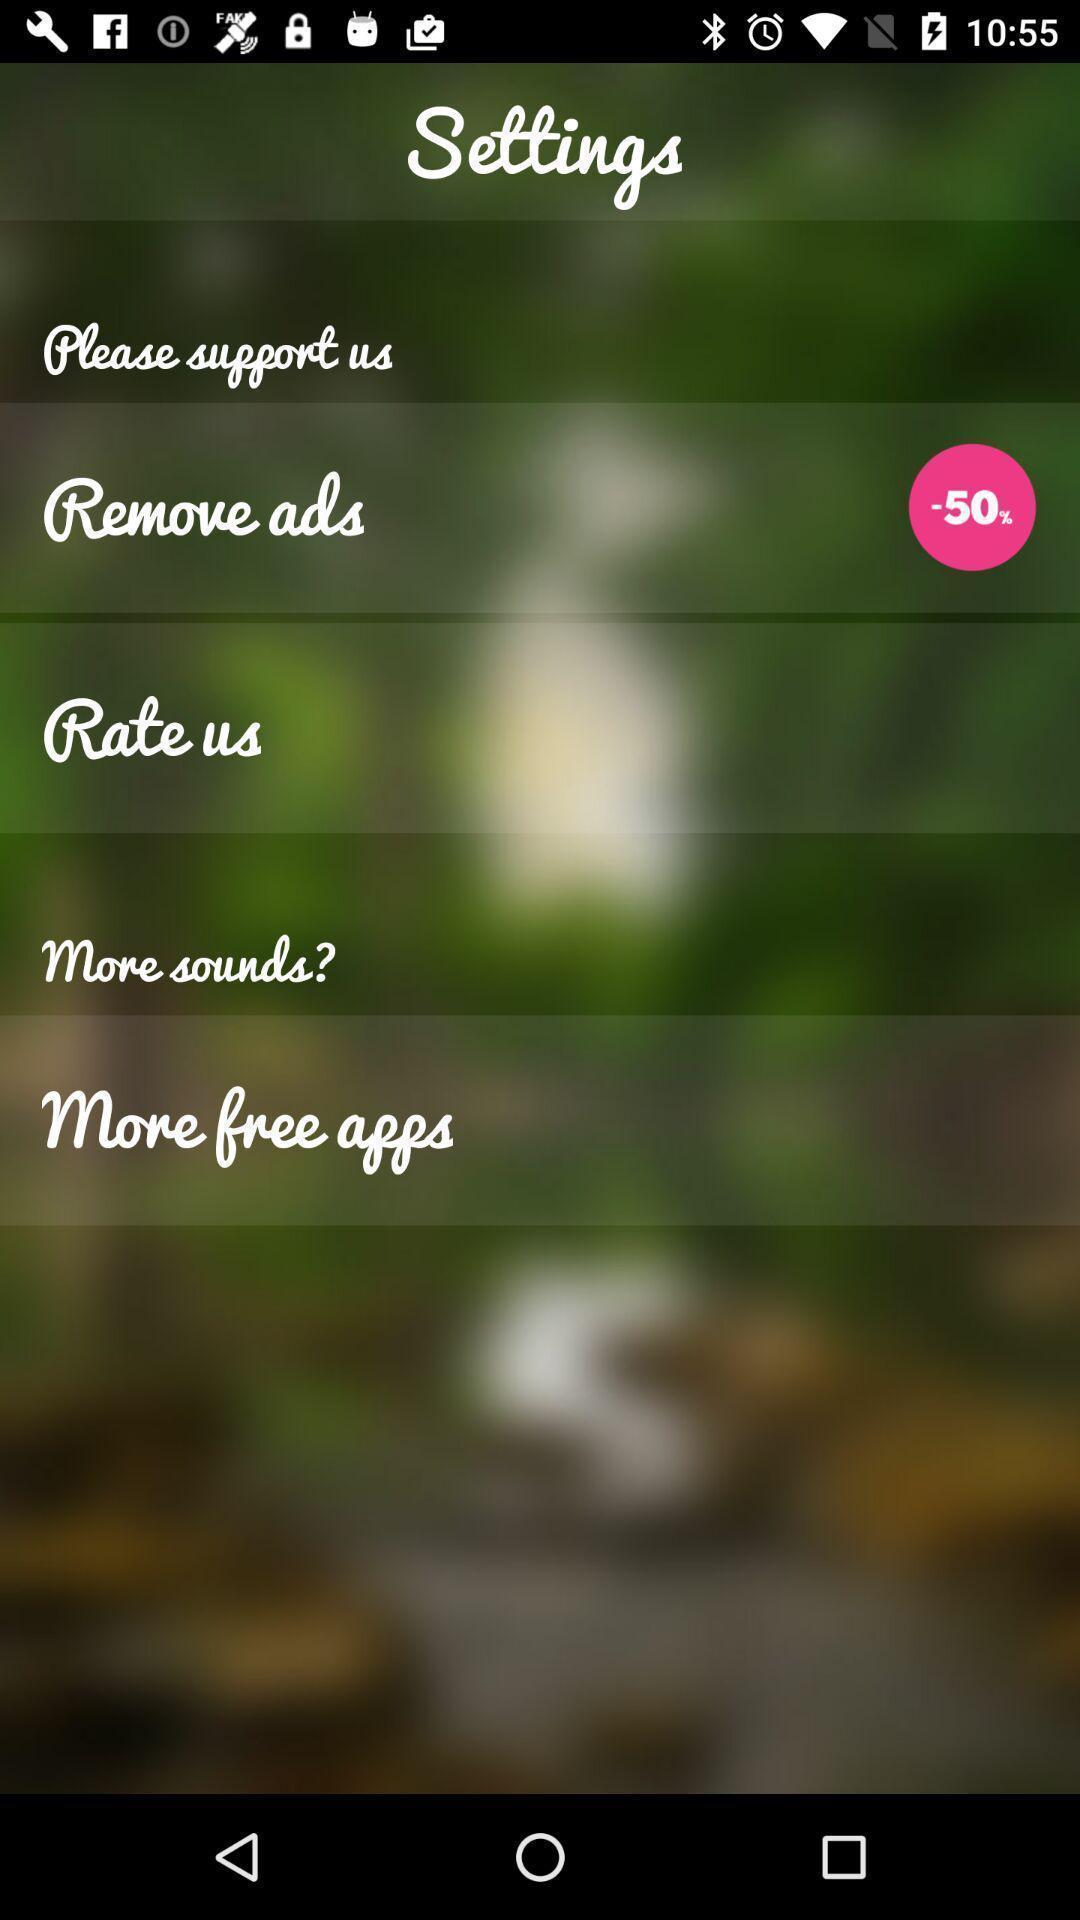Tell me what you see in this picture. Settings tab with two different options in the mobile. 